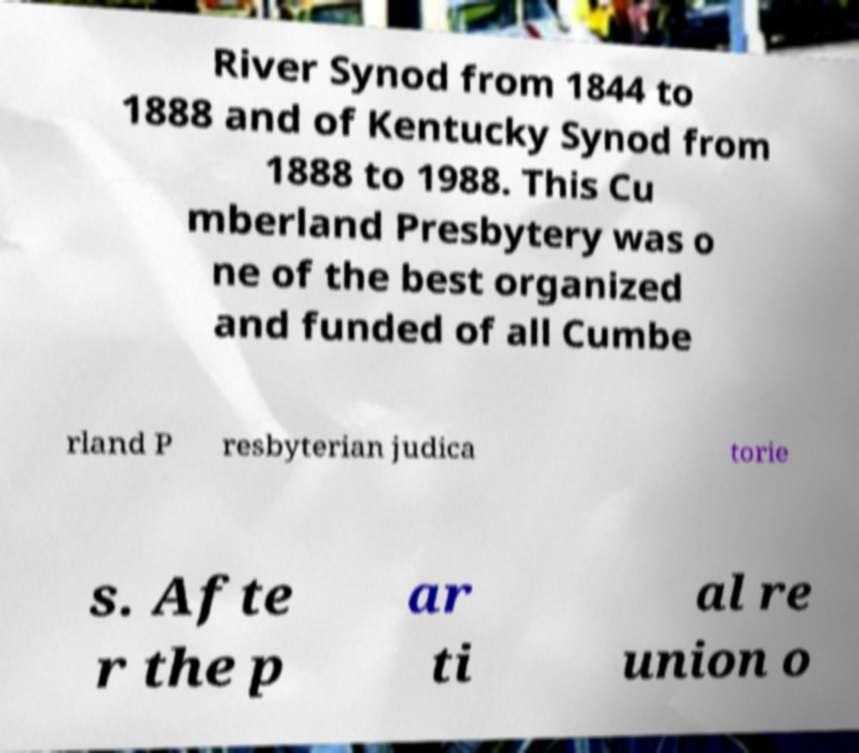Please read and relay the text visible in this image. What does it say? River Synod from 1844 to 1888 and of Kentucky Synod from 1888 to 1988. This Cu mberland Presbytery was o ne of the best organized and funded of all Cumbe rland P resbyterian judica torie s. Afte r the p ar ti al re union o 